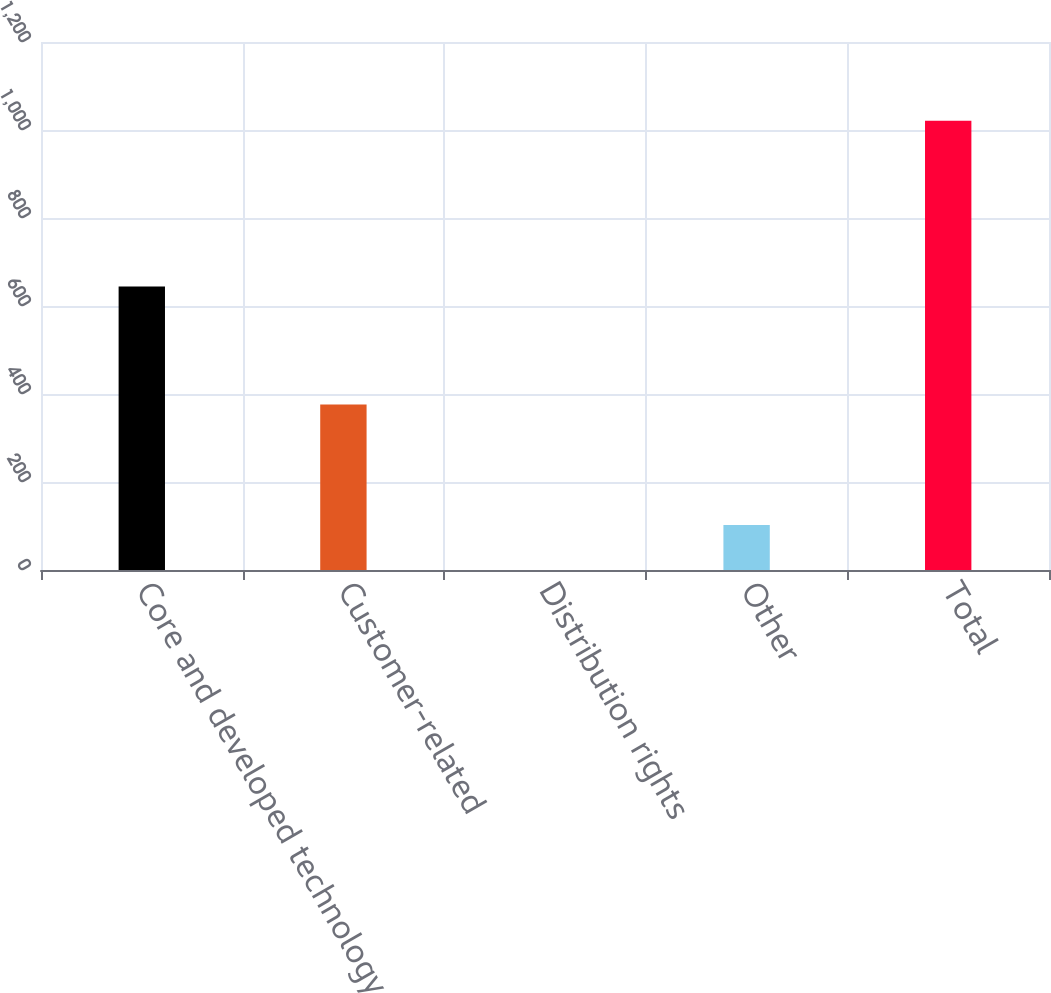Convert chart. <chart><loc_0><loc_0><loc_500><loc_500><bar_chart><fcel>Core and developed technology<fcel>Customer-related<fcel>Distribution rights<fcel>Other<fcel>Total<nl><fcel>644.4<fcel>375.9<fcel>0.1<fcel>102.2<fcel>1021.1<nl></chart> 